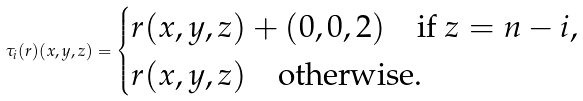Convert formula to latex. <formula><loc_0><loc_0><loc_500><loc_500>\tau _ { i } ( r ) ( x , y , z ) = \begin{cases} r ( x , y , z ) + ( 0 , 0 , 2 ) \quad \text {if } z = n - i , \\ r ( x , y , z ) \quad \text {otherwise.} \end{cases}</formula> 